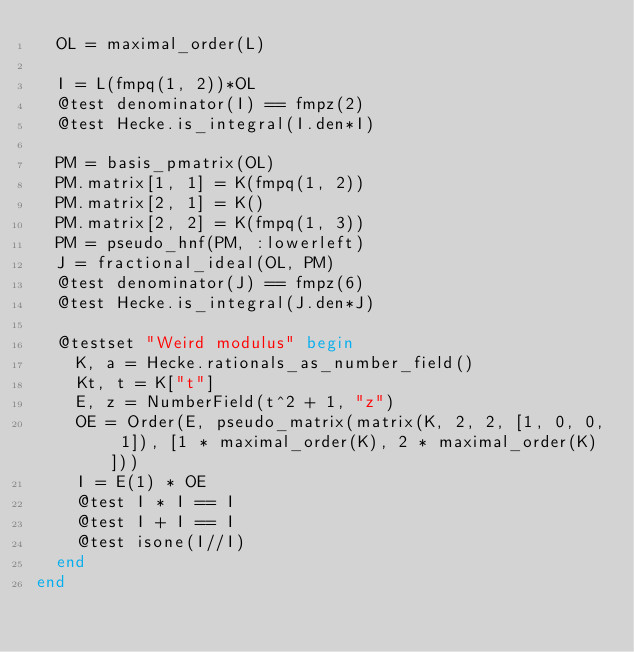Convert code to text. <code><loc_0><loc_0><loc_500><loc_500><_Julia_>  OL = maximal_order(L)

  I = L(fmpq(1, 2))*OL
  @test denominator(I) == fmpz(2)
  @test Hecke.is_integral(I.den*I)

  PM = basis_pmatrix(OL)
  PM.matrix[1, 1] = K(fmpq(1, 2))
  PM.matrix[2, 1] = K()
  PM.matrix[2, 2] = K(fmpq(1, 3))
  PM = pseudo_hnf(PM, :lowerleft)
  J = fractional_ideal(OL, PM)
  @test denominator(J) == fmpz(6)
  @test Hecke.is_integral(J.den*J)

  @testset "Weird modulus" begin
    K, a = Hecke.rationals_as_number_field()
    Kt, t = K["t"]
    E, z = NumberField(t^2 + 1, "z")
    OE = Order(E, pseudo_matrix(matrix(K, 2, 2, [1, 0, 0, 1]), [1 * maximal_order(K), 2 * maximal_order(K)]))
    I = E(1) * OE
    @test I * I == I
    @test I + I == I
    @test isone(I//I)
  end
end
</code> 